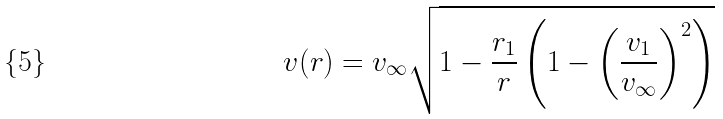<formula> <loc_0><loc_0><loc_500><loc_500>v ( r ) = v _ { \infty } \sqrt { 1 - \frac { r _ { 1 } } { r } \left ( 1 - \left ( \frac { v _ { 1 } } { v _ { \infty } } \right ) ^ { 2 } \right ) }</formula> 